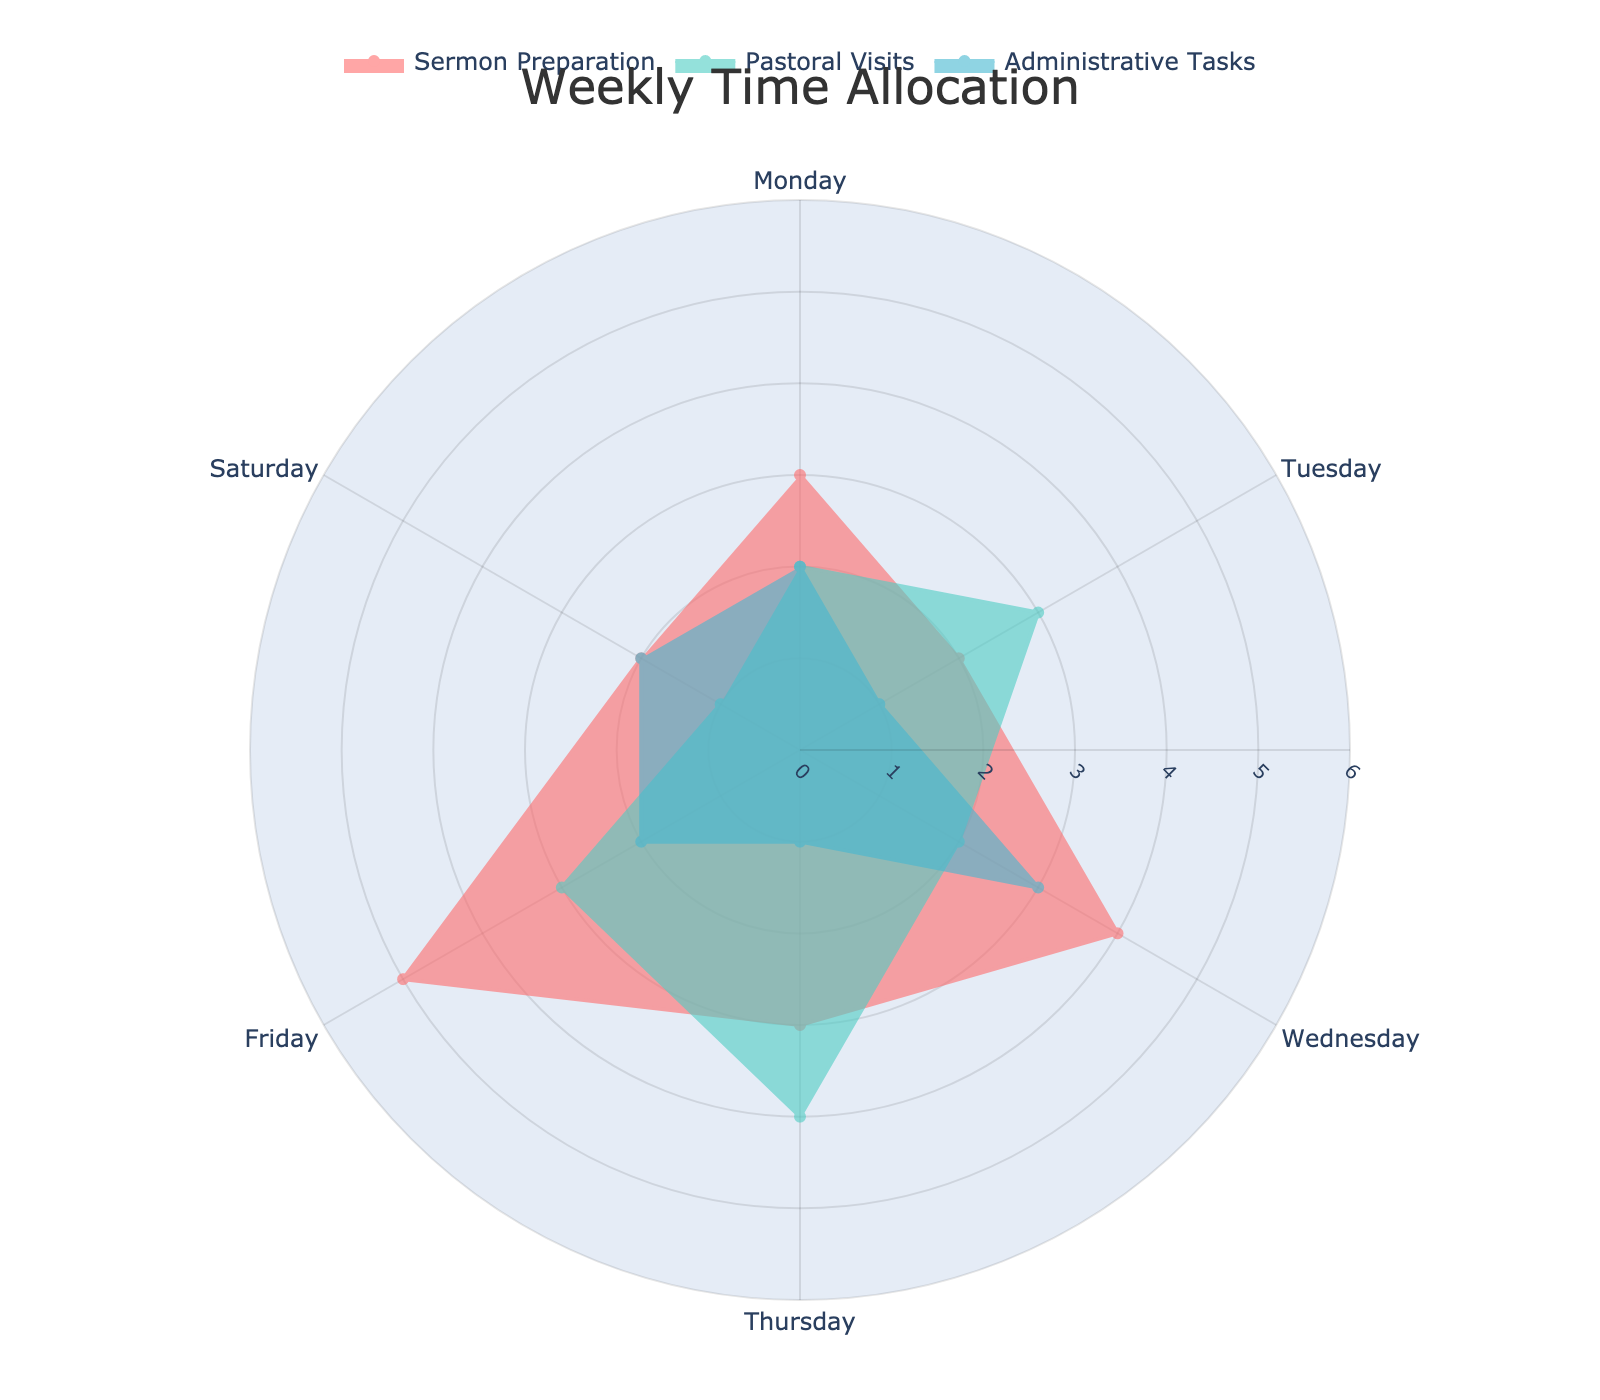What is the title of the plot? The title is usually displayed prominently at the top of the figure, which clearly states the main focus or summary of the figure.
Answer: Weekly Time Allocation Which category has the highest total hours on Wednesday? By examining the radial points plotted for Wednesday and comparing their lengths, the category with the largest extension from the center represents the highest hours.
Answer: Sermon Preparation What is the combined number of hours spent on 'Home Visits' throughout the week? Sum the hours spent on 'Home Visits' on Tuesday and Thursday as listed in the Pastoral Visits category.
Answer: 7 hours On which day is the least amount of time spent on Administrative Tasks? Look at the length of the radial axis points for Administrative Tasks across all days, the shortest one indicates the least hours.
Answer: Tuesday or Thursday (both 1 hour) Which category shows the highest variability in hours across the week? Variability can be assessed by noting the extent of the differences in the radial lines for each category. The category with the largest fluctuation indicates the highest variance.
Answer: Pastoral Visits How do the hours spent on Drafting Sermon on Friday compare to those spent Finalizing Sermon on Saturday? Compare the radial points for both 'Draft Sermon' on Friday and 'Finalize Sermon' on Saturday within the Sermon Preparation category.
Answer: 5 hours (Draft Sermon) vs 2 hours (Finalize Sermon) What is the total number of hours spent on Monday across all categories? Sum the Monday values from each category's radial information.
Answer: 7 hours (3 + 2 + 2) Which day has the highest total hours across all activities and categories combined? Sum the hours for each day from all categories and compare the totals to determine the highest.
Answer: Wednesday How do the hours for Worship Service Planning on Wednesday compare to the hours for Church Management on Wednesday? Look at the radial lengths for both activities under their respective categories on Wednesday's axis.
Answer: 4 hours (Worship Service Planning) vs 3 hours (Church Management) What patterns can be observed from the plot regarding time allocation trends during the week? Analyze the radial lengths and the day-by-day distribution of hours across all categories to identify any discernible trends or repeated behavior throughout the week.
Answer: More time is spent on pastoral visits towards the end of the week, and administrative tasks are relatively consistent with fewer hours 